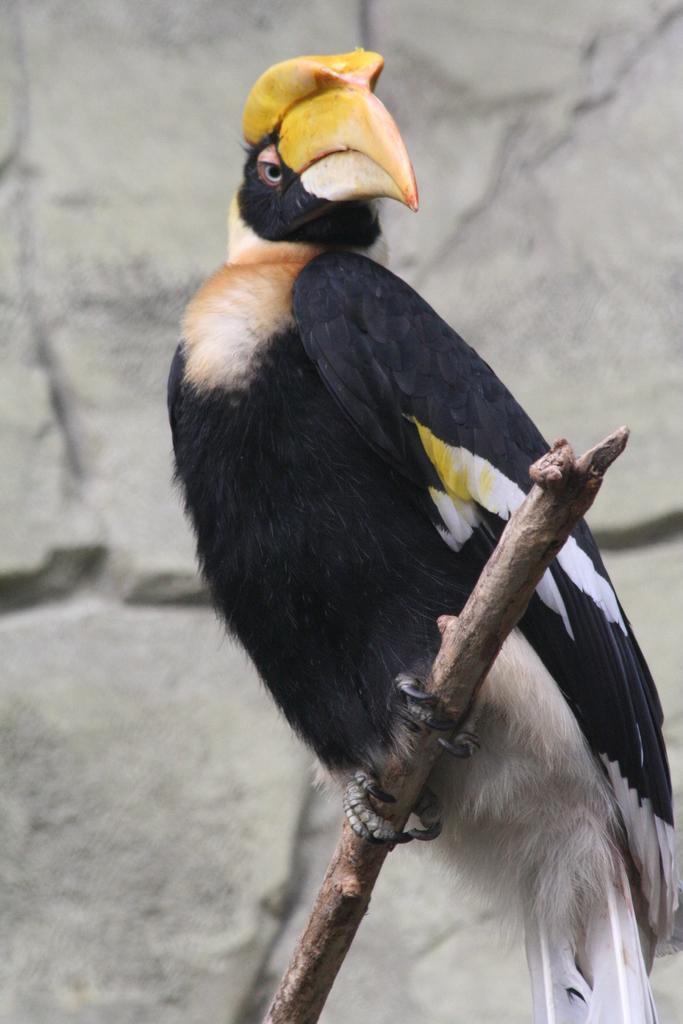Describe this image in one or two sentences. In this image we can see a bird sitting on a wooden object. There is a rock wall in the image. 